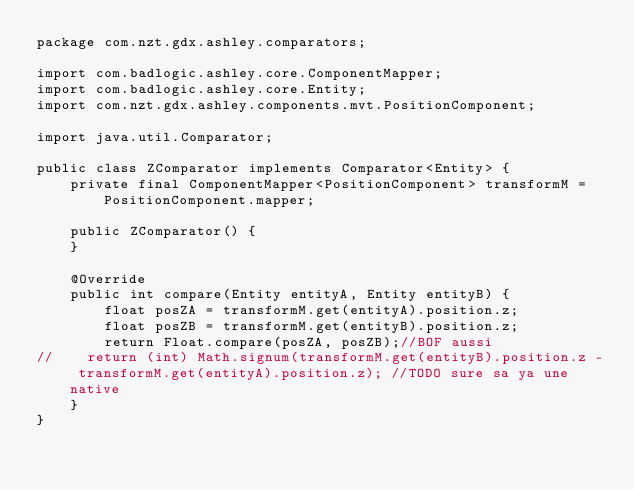Convert code to text. <code><loc_0><loc_0><loc_500><loc_500><_Java_>package com.nzt.gdx.ashley.comparators;

import com.badlogic.ashley.core.ComponentMapper;
import com.badlogic.ashley.core.Entity;
import com.nzt.gdx.ashley.components.mvt.PositionComponent;

import java.util.Comparator;

public class ZComparator implements Comparator<Entity> {
    private final ComponentMapper<PositionComponent> transformM = PositionComponent.mapper;

    public ZComparator() {
    }

    @Override
    public int compare(Entity entityA, Entity entityB) {
        float posZA = transformM.get(entityA).position.z;
        float posZB = transformM.get(entityB).position.z;
        return Float.compare(posZA, posZB);//BOF aussi
//		return (int) Math.signum(transformM.get(entityB).position.z - transformM.get(entityA).position.z); //TODO sure sa ya une native
    }
}
</code> 